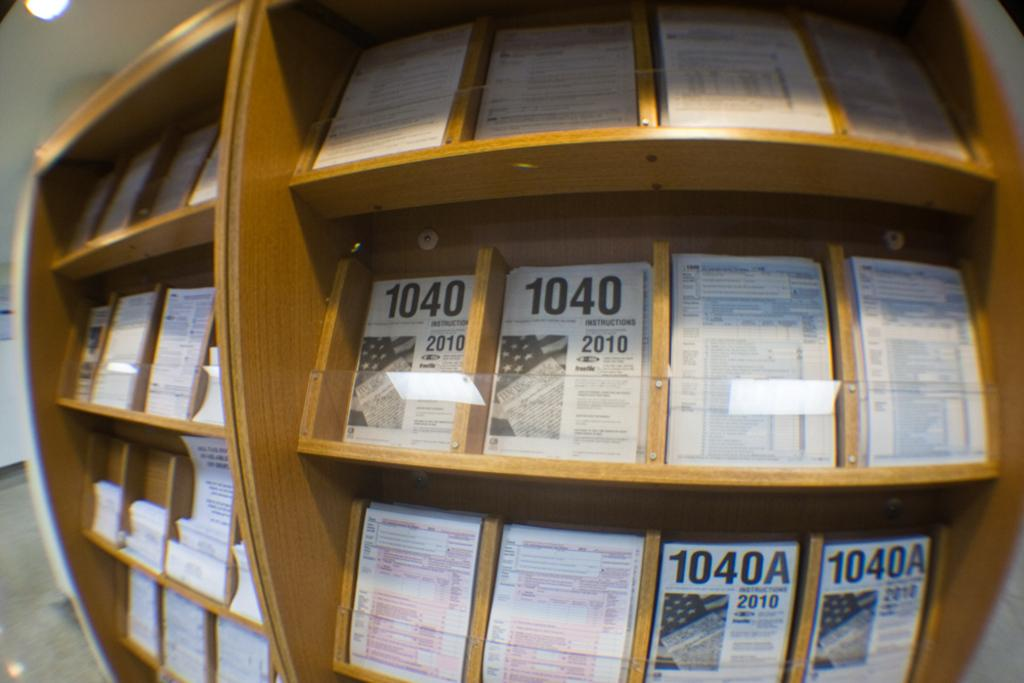<image>
Present a compact description of the photo's key features. Shelves in a public place hold forms 1040 and 1040A. 